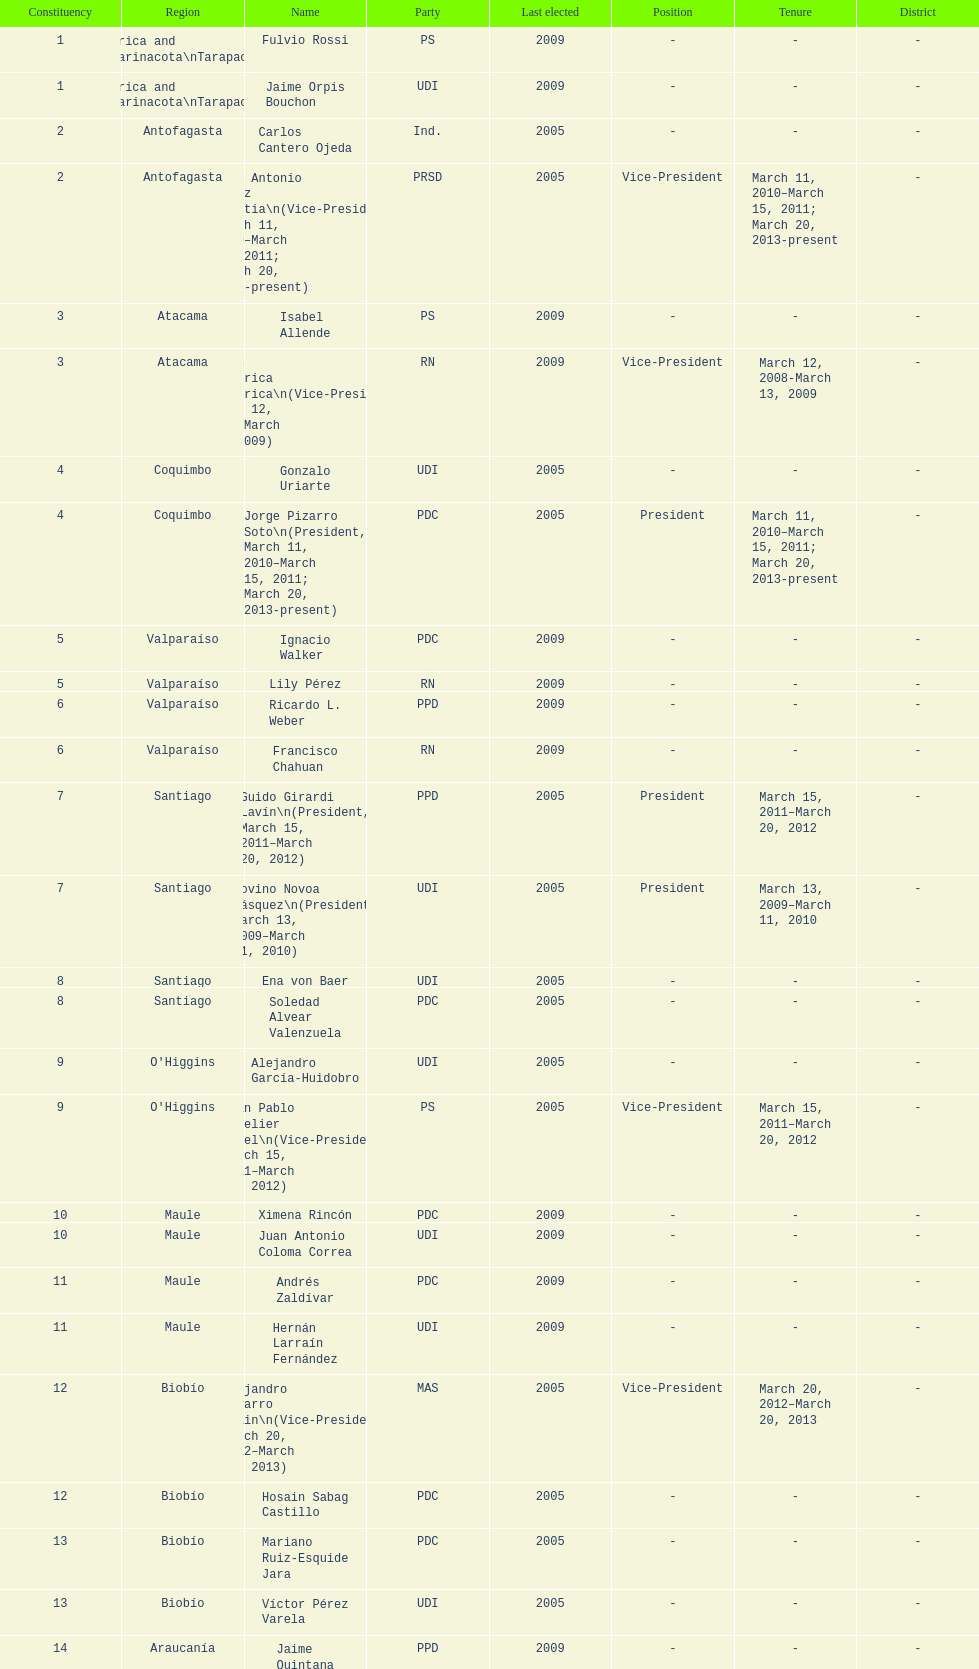What is the last region listed on the table? Magallanes. 